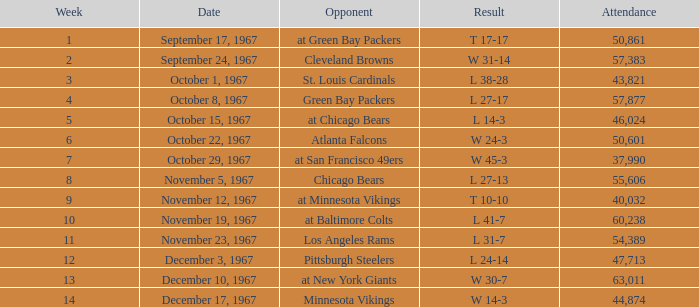Which consequence is experienced by an adversary of minnesota vikings? W 14-3. 